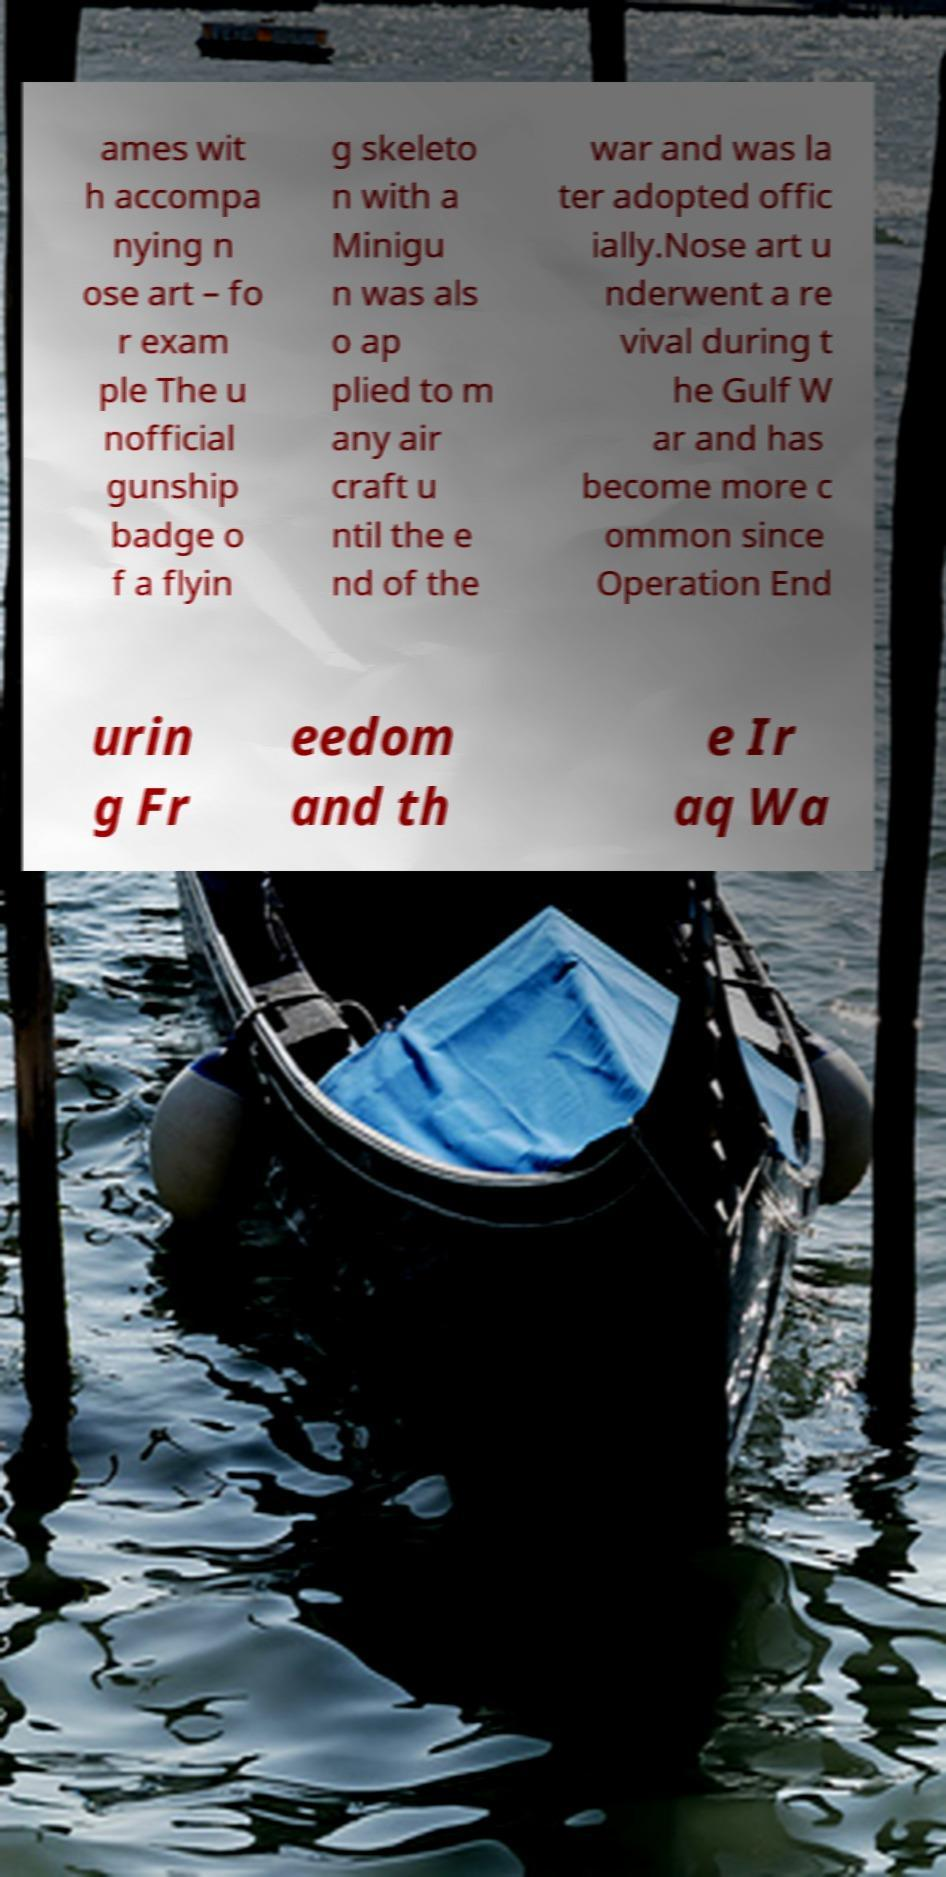There's text embedded in this image that I need extracted. Can you transcribe it verbatim? ames wit h accompa nying n ose art – fo r exam ple The u nofficial gunship badge o f a flyin g skeleto n with a Minigu n was als o ap plied to m any air craft u ntil the e nd of the war and was la ter adopted offic ially.Nose art u nderwent a re vival during t he Gulf W ar and has become more c ommon since Operation End urin g Fr eedom and th e Ir aq Wa 